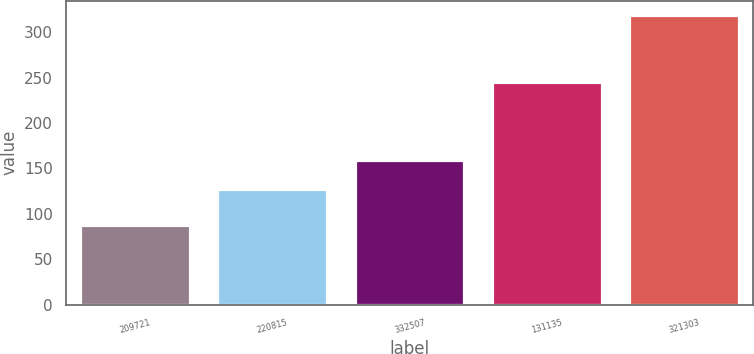<chart> <loc_0><loc_0><loc_500><loc_500><bar_chart><fcel>209721<fcel>220815<fcel>332507<fcel>131135<fcel>321303<nl><fcel>87.36<fcel>127.63<fcel>159.62<fcel>244.99<fcel>318.83<nl></chart> 